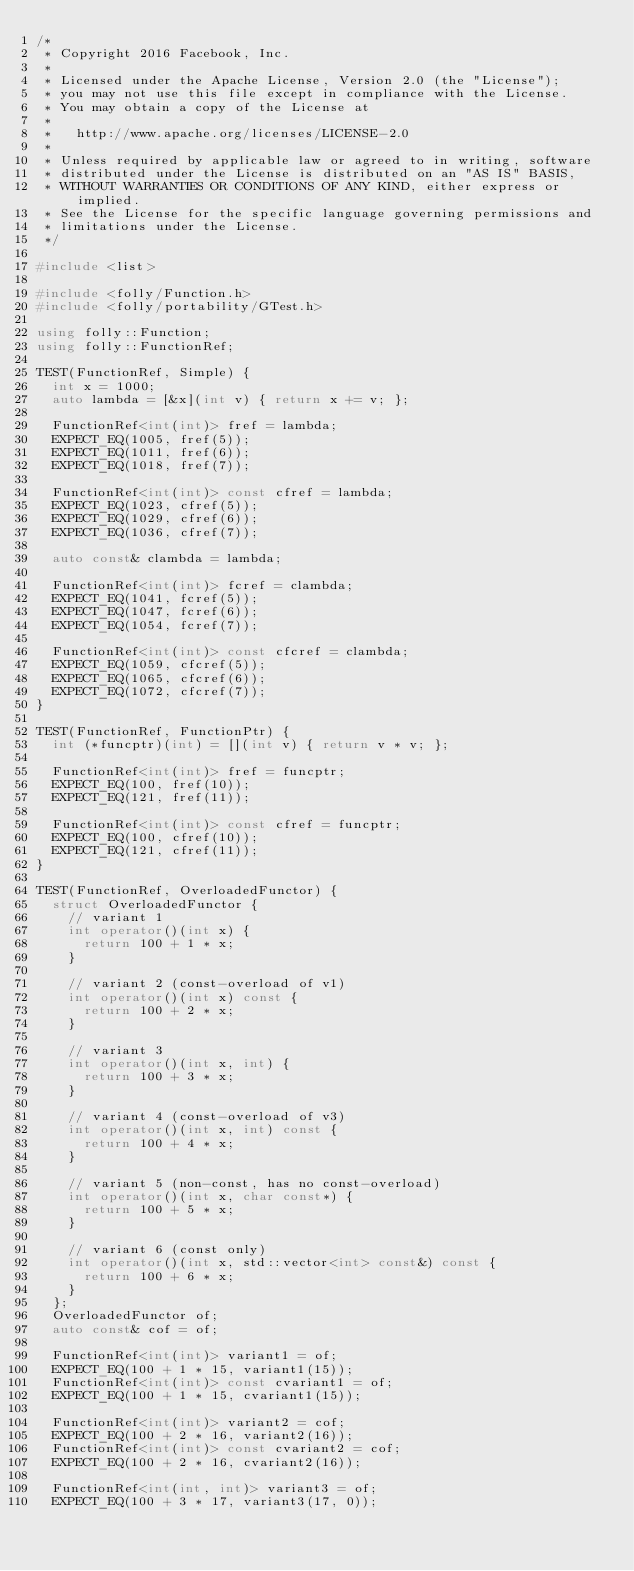Convert code to text. <code><loc_0><loc_0><loc_500><loc_500><_C++_>/*
 * Copyright 2016 Facebook, Inc.
 *
 * Licensed under the Apache License, Version 2.0 (the "License");
 * you may not use this file except in compliance with the License.
 * You may obtain a copy of the License at
 *
 *   http://www.apache.org/licenses/LICENSE-2.0
 *
 * Unless required by applicable law or agreed to in writing, software
 * distributed under the License is distributed on an "AS IS" BASIS,
 * WITHOUT WARRANTIES OR CONDITIONS OF ANY KIND, either express or implied.
 * See the License for the specific language governing permissions and
 * limitations under the License.
 */

#include <list>

#include <folly/Function.h>
#include <folly/portability/GTest.h>

using folly::Function;
using folly::FunctionRef;

TEST(FunctionRef, Simple) {
  int x = 1000;
  auto lambda = [&x](int v) { return x += v; };

  FunctionRef<int(int)> fref = lambda;
  EXPECT_EQ(1005, fref(5));
  EXPECT_EQ(1011, fref(6));
  EXPECT_EQ(1018, fref(7));

  FunctionRef<int(int)> const cfref = lambda;
  EXPECT_EQ(1023, cfref(5));
  EXPECT_EQ(1029, cfref(6));
  EXPECT_EQ(1036, cfref(7));

  auto const& clambda = lambda;

  FunctionRef<int(int)> fcref = clambda;
  EXPECT_EQ(1041, fcref(5));
  EXPECT_EQ(1047, fcref(6));
  EXPECT_EQ(1054, fcref(7));

  FunctionRef<int(int)> const cfcref = clambda;
  EXPECT_EQ(1059, cfcref(5));
  EXPECT_EQ(1065, cfcref(6));
  EXPECT_EQ(1072, cfcref(7));
}

TEST(FunctionRef, FunctionPtr) {
  int (*funcptr)(int) = [](int v) { return v * v; };

  FunctionRef<int(int)> fref = funcptr;
  EXPECT_EQ(100, fref(10));
  EXPECT_EQ(121, fref(11));

  FunctionRef<int(int)> const cfref = funcptr;
  EXPECT_EQ(100, cfref(10));
  EXPECT_EQ(121, cfref(11));
}

TEST(FunctionRef, OverloadedFunctor) {
  struct OverloadedFunctor {
    // variant 1
    int operator()(int x) {
      return 100 + 1 * x;
    }

    // variant 2 (const-overload of v1)
    int operator()(int x) const {
      return 100 + 2 * x;
    }

    // variant 3
    int operator()(int x, int) {
      return 100 + 3 * x;
    }

    // variant 4 (const-overload of v3)
    int operator()(int x, int) const {
      return 100 + 4 * x;
    }

    // variant 5 (non-const, has no const-overload)
    int operator()(int x, char const*) {
      return 100 + 5 * x;
    }

    // variant 6 (const only)
    int operator()(int x, std::vector<int> const&) const {
      return 100 + 6 * x;
    }
  };
  OverloadedFunctor of;
  auto const& cof = of;

  FunctionRef<int(int)> variant1 = of;
  EXPECT_EQ(100 + 1 * 15, variant1(15));
  FunctionRef<int(int)> const cvariant1 = of;
  EXPECT_EQ(100 + 1 * 15, cvariant1(15));

  FunctionRef<int(int)> variant2 = cof;
  EXPECT_EQ(100 + 2 * 16, variant2(16));
  FunctionRef<int(int)> const cvariant2 = cof;
  EXPECT_EQ(100 + 2 * 16, cvariant2(16));

  FunctionRef<int(int, int)> variant3 = of;
  EXPECT_EQ(100 + 3 * 17, variant3(17, 0));</code> 